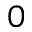Convert formula to latex. <formula><loc_0><loc_0><loc_500><loc_500>0</formula> 